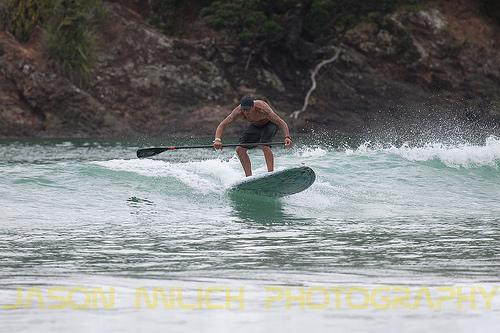Question: how does he stay on?
Choices:
A. Adhesive.
B. Balance.
C. Perseverance.
D. Will.
Answer with the letter. Answer: B Question: who rides the boards?
Choices:
A. Dogs.
B. Cats.
C. Surfers.
D. Women.
Answer with the letter. Answer: C Question: where is an oar?
Choices:
A. In his hands.
B. In the boat.
C. On the dock.
D. In the cabin.
Answer with the letter. Answer: A 